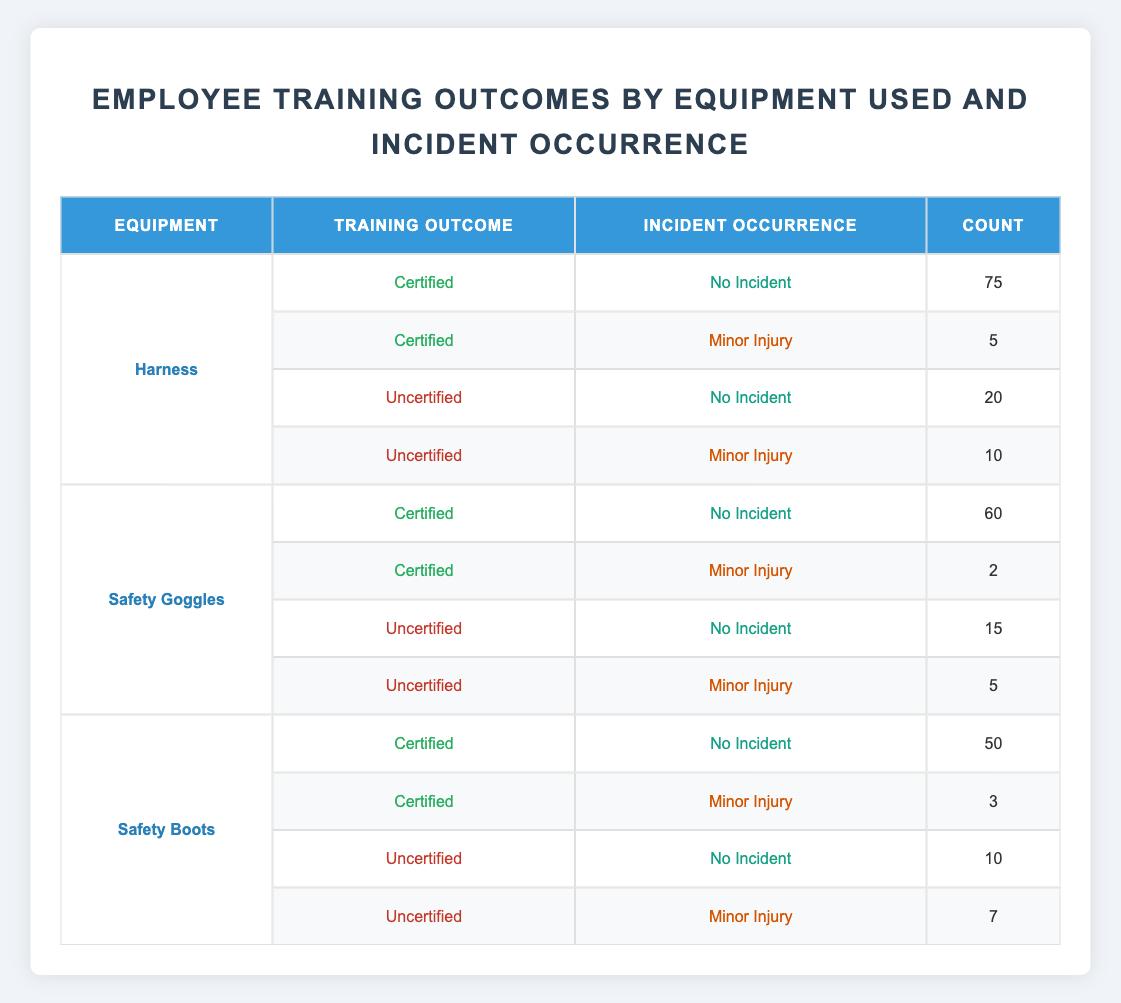What is the count of incidents for certified harness users? From the table, we can see the count of incidents for certified harness users under "Incident Occurrence" that shows "No Incident" is 75 and "Minor Injury" is 5. Therefore, the total count is 75 + 5 = 80.
Answer: 80 How many uncertified safety boot users had no incident? Looking at the table, under safety boots, the "Uncertified" training outcome shows a "No Incident" occurrence with a count of 10.
Answer: 10 Is the number of incidents for certified safety goggles users greater than for uncertified safety goggles users? For certified safety goggles, there are 60 (No Incident) + 2 (Minor Injury) = 62 incidents, while uncertified safety goggles users have 15 (No Incident) + 5 (Minor Injury) = 20 incidents. Since 62 is greater than 20, the statement is true.
Answer: Yes What is the total number of minor injuries across all equipment? To find this, we sum the counts of "Minor Injury" across all equipment. Harness has 5 + 10, Safety Goggles has 2 + 5, and Safety Boots has 3 + 7. This gives us 15 + 7 + 10 = 32 minor injuries in total.
Answer: 32 How many more no incident occurrences are there for certified harness users compared to uncertified harness users? From the table, "Certified" harness users have 75 (No Incident) while "Uncertified" harness users have 20 (No Incident). The difference is 75 - 20 = 55.
Answer: 55 What percentage of certified safety boot users experienced minor injuries? Certified safety boots users have 50 (No Incident) and 3 (Minor Injury). The percentage is calculated as (3 / (50 + 3)) * 100 = 5.66%.
Answer: 5.66% How many incidents occurred in total for safety goggles? For safety goggles, there are 60 (No Incident) and 2 (Minor Injury) for certified and 15 (No Incident) and 5 (Minor Injury) for uncertified. Adding these gives us 60 + 2 + 15 + 5 = 82 incidents in total.
Answer: 82 What is the overall count of certified training outcomes across all equipment? Counting the certified outcomes, we find 75 (Harness) + 60 (Safety Goggles) + 50 (Safety Boots) = 185.
Answer: 185 Is it true that no incidents occurred with uncertified safety goggles more than with certified safety goggles? The count of no incidents for uncertified safety goggles is 15, while for certified safety goggles, it is 60. Since 15 is not greater than 60, the statement is false.
Answer: No 